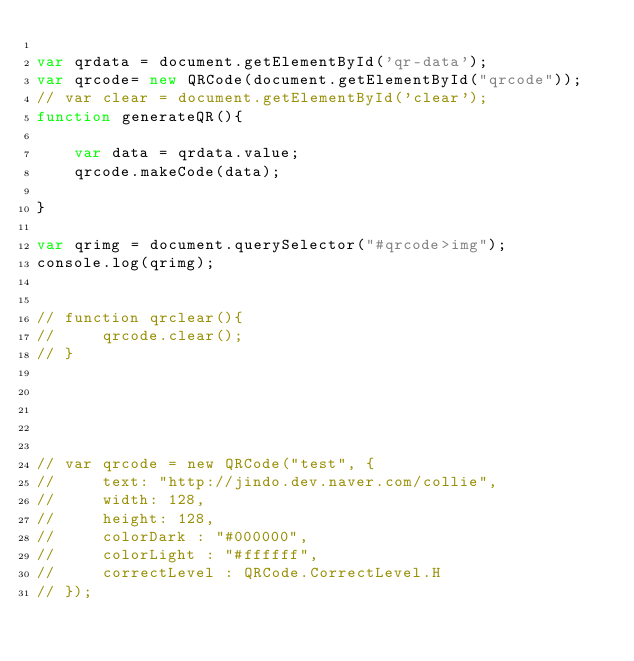Convert code to text. <code><loc_0><loc_0><loc_500><loc_500><_JavaScript_>
var qrdata = document.getElementById('qr-data');
var qrcode= new QRCode(document.getElementById("qrcode"));
// var clear = document.getElementById('clear');
function generateQR(){

    var data = qrdata.value;
    qrcode.makeCode(data);
    
}

var qrimg = document.querySelector("#qrcode>img");
console.log(qrimg);


// function qrclear(){
//     qrcode.clear();
// }





// var qrcode = new QRCode("test", {
//     text: "http://jindo.dev.naver.com/collie",
//     width: 128,
//     height: 128,
//     colorDark : "#000000",
//     colorLight : "#ffffff",
//     correctLevel : QRCode.CorrectLevel.H
// });</code> 